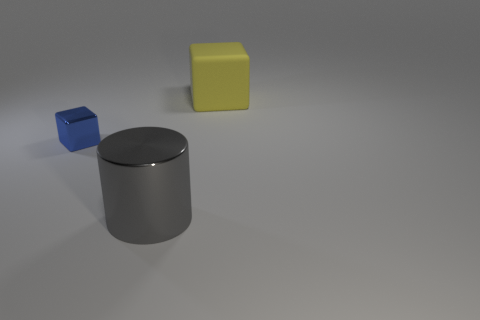Add 2 cylinders. How many objects exist? 5 Subtract 0 green cubes. How many objects are left? 3 Subtract all cylinders. How many objects are left? 2 Subtract 1 cubes. How many cubes are left? 1 Subtract all brown cylinders. Subtract all gray cubes. How many cylinders are left? 1 Subtract all red cylinders. How many blue blocks are left? 1 Subtract all tiny brown rubber things. Subtract all shiny cubes. How many objects are left? 2 Add 2 blue cubes. How many blue cubes are left? 3 Add 3 large blocks. How many large blocks exist? 4 